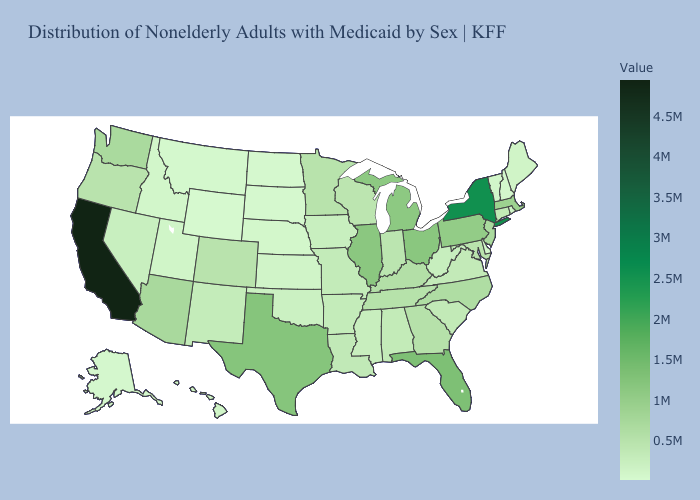Which states have the highest value in the USA?
Answer briefly. California. Among the states that border Oregon , which have the highest value?
Write a very short answer. California. Does North Dakota have a higher value than California?
Write a very short answer. No. Among the states that border New York , which have the highest value?
Keep it brief. Pennsylvania. Which states have the highest value in the USA?
Be succinct. California. Among the states that border Nevada , which have the lowest value?
Answer briefly. Idaho. 